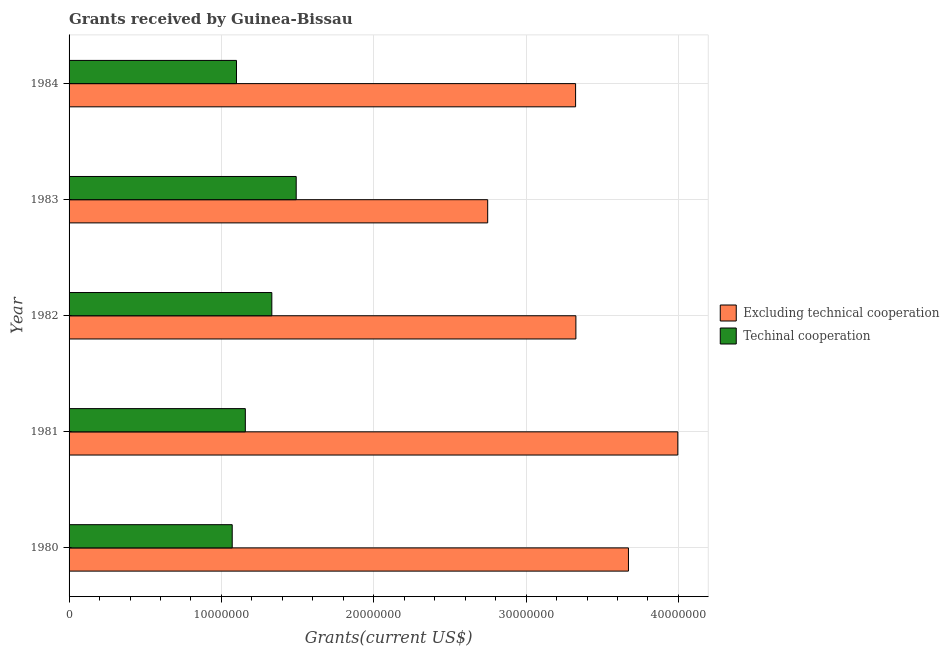Are the number of bars per tick equal to the number of legend labels?
Give a very brief answer. Yes. How many bars are there on the 5th tick from the top?
Provide a succinct answer. 2. In how many cases, is the number of bars for a given year not equal to the number of legend labels?
Keep it short and to the point. 0. What is the amount of grants received(including technical cooperation) in 1981?
Your response must be concise. 1.16e+07. Across all years, what is the maximum amount of grants received(excluding technical cooperation)?
Your answer should be compact. 4.00e+07. Across all years, what is the minimum amount of grants received(excluding technical cooperation)?
Your answer should be compact. 2.75e+07. In which year was the amount of grants received(including technical cooperation) maximum?
Offer a terse response. 1983. What is the total amount of grants received(excluding technical cooperation) in the graph?
Ensure brevity in your answer.  1.71e+08. What is the difference between the amount of grants received(excluding technical cooperation) in 1981 and that in 1982?
Ensure brevity in your answer.  6.69e+06. What is the difference between the amount of grants received(including technical cooperation) in 1981 and the amount of grants received(excluding technical cooperation) in 1982?
Give a very brief answer. -2.17e+07. What is the average amount of grants received(excluding technical cooperation) per year?
Your response must be concise. 3.41e+07. In the year 1984, what is the difference between the amount of grants received(excluding technical cooperation) and amount of grants received(including technical cooperation)?
Ensure brevity in your answer.  2.23e+07. In how many years, is the amount of grants received(excluding technical cooperation) greater than 26000000 US$?
Give a very brief answer. 5. What is the ratio of the amount of grants received(including technical cooperation) in 1980 to that in 1982?
Make the answer very short. 0.81. Is the amount of grants received(excluding technical cooperation) in 1980 less than that in 1981?
Provide a short and direct response. Yes. What is the difference between the highest and the second highest amount of grants received(including technical cooperation)?
Your response must be concise. 1.60e+06. What is the difference between the highest and the lowest amount of grants received(excluding technical cooperation)?
Your answer should be compact. 1.25e+07. What does the 2nd bar from the top in 1982 represents?
Keep it short and to the point. Excluding technical cooperation. What does the 2nd bar from the bottom in 1982 represents?
Provide a short and direct response. Techinal cooperation. Are the values on the major ticks of X-axis written in scientific E-notation?
Your answer should be very brief. No. Does the graph contain any zero values?
Offer a terse response. No. Does the graph contain grids?
Your answer should be compact. Yes. What is the title of the graph?
Keep it short and to the point. Grants received by Guinea-Bissau. What is the label or title of the X-axis?
Your answer should be compact. Grants(current US$). What is the Grants(current US$) in Excluding technical cooperation in 1980?
Your answer should be very brief. 3.67e+07. What is the Grants(current US$) in Techinal cooperation in 1980?
Ensure brevity in your answer.  1.07e+07. What is the Grants(current US$) in Excluding technical cooperation in 1981?
Offer a terse response. 4.00e+07. What is the Grants(current US$) of Techinal cooperation in 1981?
Your answer should be compact. 1.16e+07. What is the Grants(current US$) of Excluding technical cooperation in 1982?
Offer a very short reply. 3.33e+07. What is the Grants(current US$) in Techinal cooperation in 1982?
Your answer should be very brief. 1.33e+07. What is the Grants(current US$) in Excluding technical cooperation in 1983?
Your response must be concise. 2.75e+07. What is the Grants(current US$) in Techinal cooperation in 1983?
Offer a terse response. 1.49e+07. What is the Grants(current US$) in Excluding technical cooperation in 1984?
Your answer should be compact. 3.32e+07. What is the Grants(current US$) of Techinal cooperation in 1984?
Keep it short and to the point. 1.10e+07. Across all years, what is the maximum Grants(current US$) of Excluding technical cooperation?
Provide a succinct answer. 4.00e+07. Across all years, what is the maximum Grants(current US$) of Techinal cooperation?
Your answer should be very brief. 1.49e+07. Across all years, what is the minimum Grants(current US$) of Excluding technical cooperation?
Provide a succinct answer. 2.75e+07. Across all years, what is the minimum Grants(current US$) in Techinal cooperation?
Your response must be concise. 1.07e+07. What is the total Grants(current US$) in Excluding technical cooperation in the graph?
Offer a very short reply. 1.71e+08. What is the total Grants(current US$) in Techinal cooperation in the graph?
Your answer should be compact. 6.15e+07. What is the difference between the Grants(current US$) of Excluding technical cooperation in 1980 and that in 1981?
Your answer should be very brief. -3.24e+06. What is the difference between the Grants(current US$) in Techinal cooperation in 1980 and that in 1981?
Make the answer very short. -8.60e+05. What is the difference between the Grants(current US$) in Excluding technical cooperation in 1980 and that in 1982?
Your answer should be compact. 3.45e+06. What is the difference between the Grants(current US$) in Techinal cooperation in 1980 and that in 1982?
Your answer should be very brief. -2.60e+06. What is the difference between the Grants(current US$) in Excluding technical cooperation in 1980 and that in 1983?
Give a very brief answer. 9.24e+06. What is the difference between the Grants(current US$) in Techinal cooperation in 1980 and that in 1983?
Offer a terse response. -4.20e+06. What is the difference between the Grants(current US$) in Excluding technical cooperation in 1980 and that in 1984?
Provide a succinct answer. 3.47e+06. What is the difference between the Grants(current US$) of Techinal cooperation in 1980 and that in 1984?
Ensure brevity in your answer.  -2.80e+05. What is the difference between the Grants(current US$) in Excluding technical cooperation in 1981 and that in 1982?
Give a very brief answer. 6.69e+06. What is the difference between the Grants(current US$) of Techinal cooperation in 1981 and that in 1982?
Provide a short and direct response. -1.74e+06. What is the difference between the Grants(current US$) of Excluding technical cooperation in 1981 and that in 1983?
Give a very brief answer. 1.25e+07. What is the difference between the Grants(current US$) in Techinal cooperation in 1981 and that in 1983?
Your answer should be very brief. -3.34e+06. What is the difference between the Grants(current US$) in Excluding technical cooperation in 1981 and that in 1984?
Ensure brevity in your answer.  6.71e+06. What is the difference between the Grants(current US$) in Techinal cooperation in 1981 and that in 1984?
Give a very brief answer. 5.80e+05. What is the difference between the Grants(current US$) in Excluding technical cooperation in 1982 and that in 1983?
Your answer should be compact. 5.79e+06. What is the difference between the Grants(current US$) in Techinal cooperation in 1982 and that in 1983?
Provide a succinct answer. -1.60e+06. What is the difference between the Grants(current US$) in Excluding technical cooperation in 1982 and that in 1984?
Keep it short and to the point. 2.00e+04. What is the difference between the Grants(current US$) in Techinal cooperation in 1982 and that in 1984?
Provide a succinct answer. 2.32e+06. What is the difference between the Grants(current US$) of Excluding technical cooperation in 1983 and that in 1984?
Give a very brief answer. -5.77e+06. What is the difference between the Grants(current US$) of Techinal cooperation in 1983 and that in 1984?
Give a very brief answer. 3.92e+06. What is the difference between the Grants(current US$) of Excluding technical cooperation in 1980 and the Grants(current US$) of Techinal cooperation in 1981?
Offer a very short reply. 2.52e+07. What is the difference between the Grants(current US$) of Excluding technical cooperation in 1980 and the Grants(current US$) of Techinal cooperation in 1982?
Offer a very short reply. 2.34e+07. What is the difference between the Grants(current US$) in Excluding technical cooperation in 1980 and the Grants(current US$) in Techinal cooperation in 1983?
Your answer should be very brief. 2.18e+07. What is the difference between the Grants(current US$) in Excluding technical cooperation in 1980 and the Grants(current US$) in Techinal cooperation in 1984?
Provide a short and direct response. 2.57e+07. What is the difference between the Grants(current US$) of Excluding technical cooperation in 1981 and the Grants(current US$) of Techinal cooperation in 1982?
Keep it short and to the point. 2.66e+07. What is the difference between the Grants(current US$) of Excluding technical cooperation in 1981 and the Grants(current US$) of Techinal cooperation in 1983?
Offer a very short reply. 2.50e+07. What is the difference between the Grants(current US$) of Excluding technical cooperation in 1981 and the Grants(current US$) of Techinal cooperation in 1984?
Give a very brief answer. 2.90e+07. What is the difference between the Grants(current US$) in Excluding technical cooperation in 1982 and the Grants(current US$) in Techinal cooperation in 1983?
Your response must be concise. 1.84e+07. What is the difference between the Grants(current US$) in Excluding technical cooperation in 1982 and the Grants(current US$) in Techinal cooperation in 1984?
Your answer should be compact. 2.23e+07. What is the difference between the Grants(current US$) of Excluding technical cooperation in 1983 and the Grants(current US$) of Techinal cooperation in 1984?
Make the answer very short. 1.65e+07. What is the average Grants(current US$) of Excluding technical cooperation per year?
Offer a terse response. 3.41e+07. What is the average Grants(current US$) in Techinal cooperation per year?
Your answer should be compact. 1.23e+07. In the year 1980, what is the difference between the Grants(current US$) of Excluding technical cooperation and Grants(current US$) of Techinal cooperation?
Give a very brief answer. 2.60e+07. In the year 1981, what is the difference between the Grants(current US$) in Excluding technical cooperation and Grants(current US$) in Techinal cooperation?
Ensure brevity in your answer.  2.84e+07. In the year 1982, what is the difference between the Grants(current US$) of Excluding technical cooperation and Grants(current US$) of Techinal cooperation?
Your answer should be compact. 2.00e+07. In the year 1983, what is the difference between the Grants(current US$) in Excluding technical cooperation and Grants(current US$) in Techinal cooperation?
Your answer should be compact. 1.26e+07. In the year 1984, what is the difference between the Grants(current US$) in Excluding technical cooperation and Grants(current US$) in Techinal cooperation?
Provide a succinct answer. 2.23e+07. What is the ratio of the Grants(current US$) of Excluding technical cooperation in 1980 to that in 1981?
Make the answer very short. 0.92. What is the ratio of the Grants(current US$) of Techinal cooperation in 1980 to that in 1981?
Your answer should be very brief. 0.93. What is the ratio of the Grants(current US$) of Excluding technical cooperation in 1980 to that in 1982?
Offer a very short reply. 1.1. What is the ratio of the Grants(current US$) in Techinal cooperation in 1980 to that in 1982?
Give a very brief answer. 0.8. What is the ratio of the Grants(current US$) of Excluding technical cooperation in 1980 to that in 1983?
Offer a very short reply. 1.34. What is the ratio of the Grants(current US$) in Techinal cooperation in 1980 to that in 1983?
Your response must be concise. 0.72. What is the ratio of the Grants(current US$) in Excluding technical cooperation in 1980 to that in 1984?
Provide a succinct answer. 1.1. What is the ratio of the Grants(current US$) in Techinal cooperation in 1980 to that in 1984?
Your response must be concise. 0.97. What is the ratio of the Grants(current US$) in Excluding technical cooperation in 1981 to that in 1982?
Your answer should be very brief. 1.2. What is the ratio of the Grants(current US$) in Techinal cooperation in 1981 to that in 1982?
Ensure brevity in your answer.  0.87. What is the ratio of the Grants(current US$) in Excluding technical cooperation in 1981 to that in 1983?
Offer a terse response. 1.45. What is the ratio of the Grants(current US$) in Techinal cooperation in 1981 to that in 1983?
Keep it short and to the point. 0.78. What is the ratio of the Grants(current US$) in Excluding technical cooperation in 1981 to that in 1984?
Provide a succinct answer. 1.2. What is the ratio of the Grants(current US$) of Techinal cooperation in 1981 to that in 1984?
Provide a succinct answer. 1.05. What is the ratio of the Grants(current US$) of Excluding technical cooperation in 1982 to that in 1983?
Make the answer very short. 1.21. What is the ratio of the Grants(current US$) of Techinal cooperation in 1982 to that in 1983?
Make the answer very short. 0.89. What is the ratio of the Grants(current US$) in Excluding technical cooperation in 1982 to that in 1984?
Ensure brevity in your answer.  1. What is the ratio of the Grants(current US$) of Techinal cooperation in 1982 to that in 1984?
Provide a succinct answer. 1.21. What is the ratio of the Grants(current US$) in Excluding technical cooperation in 1983 to that in 1984?
Your answer should be very brief. 0.83. What is the ratio of the Grants(current US$) of Techinal cooperation in 1983 to that in 1984?
Your answer should be compact. 1.36. What is the difference between the highest and the second highest Grants(current US$) in Excluding technical cooperation?
Keep it short and to the point. 3.24e+06. What is the difference between the highest and the second highest Grants(current US$) in Techinal cooperation?
Give a very brief answer. 1.60e+06. What is the difference between the highest and the lowest Grants(current US$) of Excluding technical cooperation?
Ensure brevity in your answer.  1.25e+07. What is the difference between the highest and the lowest Grants(current US$) in Techinal cooperation?
Give a very brief answer. 4.20e+06. 